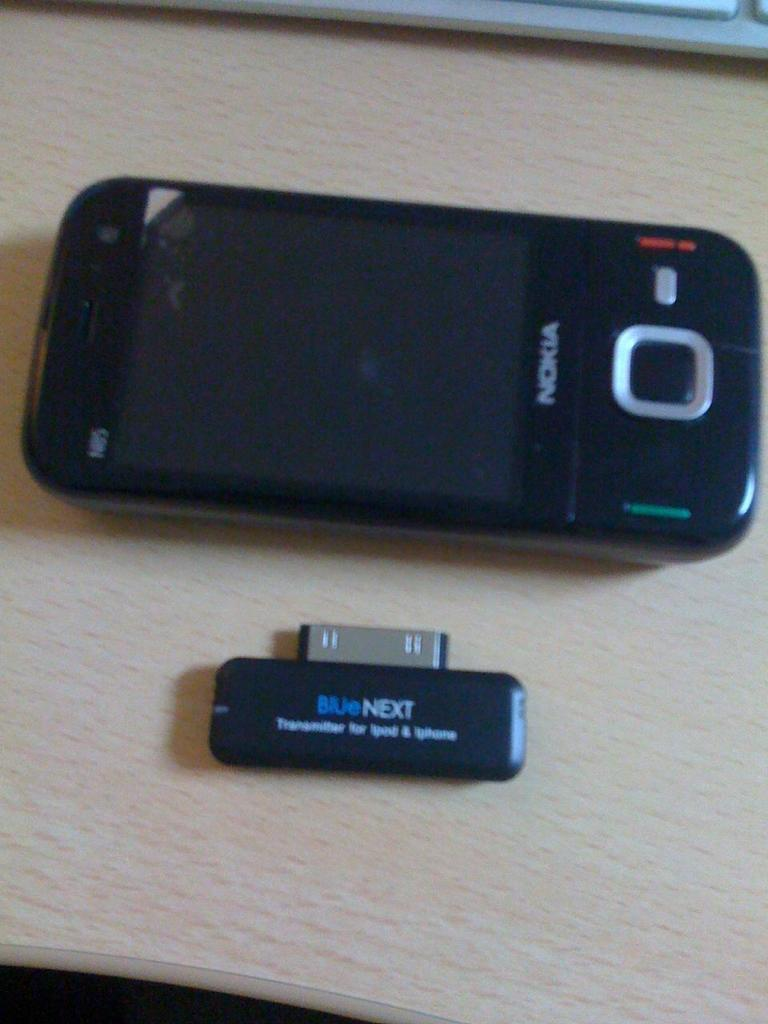<image>
Create a compact narrative representing the image presented. A black Nokia phone on a wood table with a small device attachment beside it with the words BlueNext written on it 